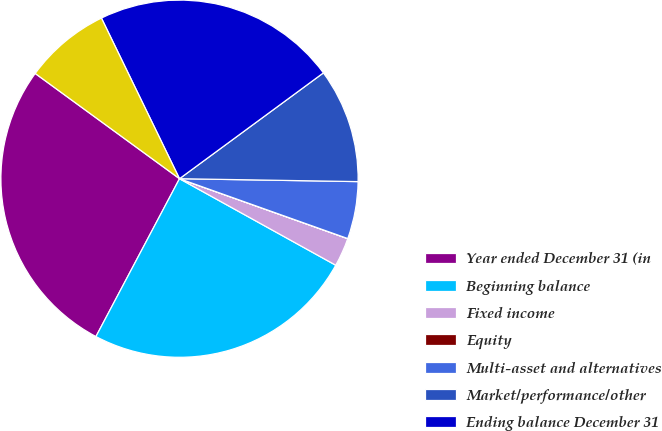Convert chart. <chart><loc_0><loc_0><loc_500><loc_500><pie_chart><fcel>Year ended December 31 (in<fcel>Beginning balance<fcel>Fixed income<fcel>Equity<fcel>Multi-asset and alternatives<fcel>Market/performance/other<fcel>Ending balance December 31<fcel>Net asset flows<nl><fcel>27.28%<fcel>24.7%<fcel>2.6%<fcel>0.01%<fcel>5.18%<fcel>10.35%<fcel>22.11%<fcel>7.77%<nl></chart> 